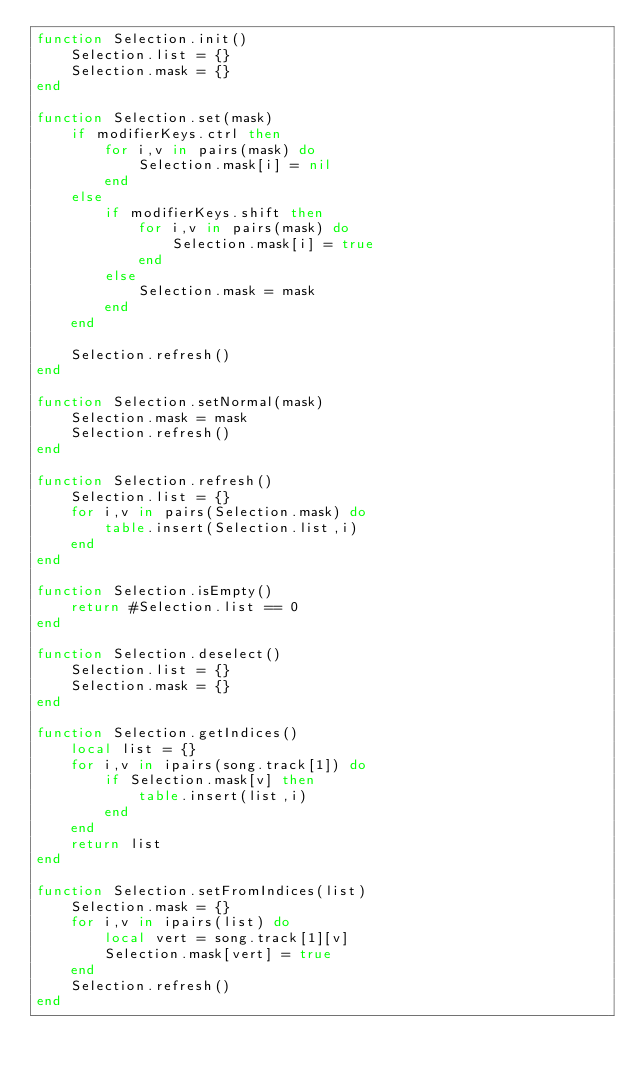Convert code to text. <code><loc_0><loc_0><loc_500><loc_500><_Lua_>function Selection.init()
	Selection.list = {}
	Selection.mask = {}
end

function Selection.set(mask)
	if modifierKeys.ctrl then
		for i,v in pairs(mask) do
			Selection.mask[i] = nil
		end
	else
		if modifierKeys.shift then
			for i,v in pairs(mask) do
				Selection.mask[i] = true
			end
		else
			Selection.mask = mask
		end
	end

	Selection.refresh()
end

function Selection.setNormal(mask)
	Selection.mask = mask
	Selection.refresh()
end

function Selection.refresh()
	Selection.list = {}
	for i,v in pairs(Selection.mask) do
		table.insert(Selection.list,i)
	end
end

function Selection.isEmpty()
	return #Selection.list == 0
end

function Selection.deselect()
	Selection.list = {}
	Selection.mask = {}
end

function Selection.getIndices()
	local list = {}
	for i,v in ipairs(song.track[1]) do
		if Selection.mask[v] then
			table.insert(list,i)
		end
	end
	return list
end

function Selection.setFromIndices(list)
	Selection.mask = {}
	for i,v in ipairs(list) do
		local vert = song.track[1][v]
		Selection.mask[vert] = true
	end
	Selection.refresh()
end</code> 